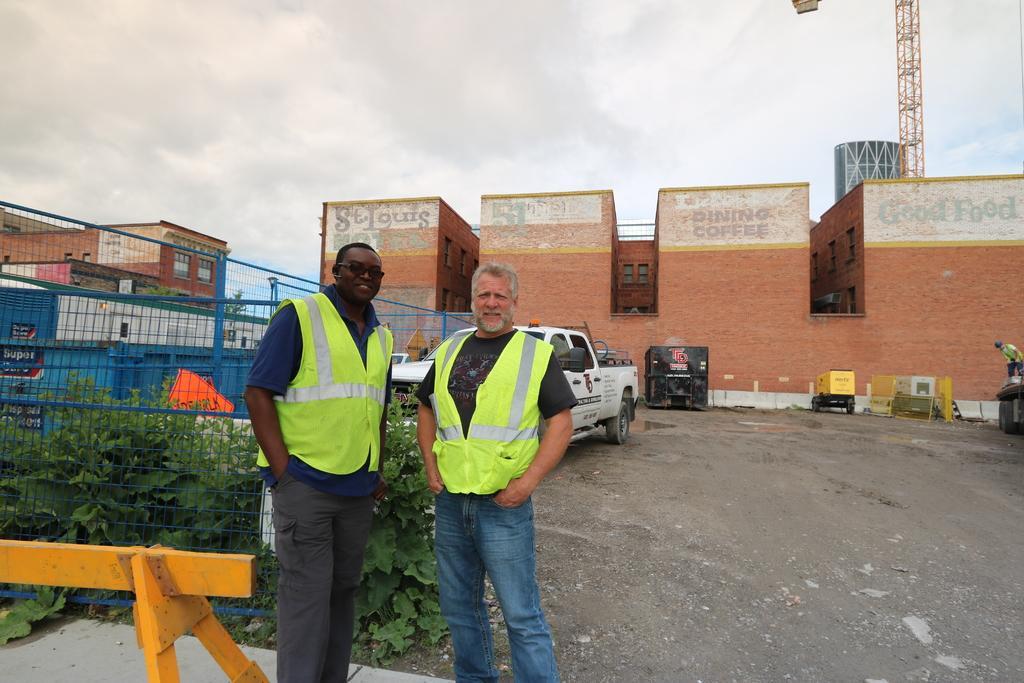In one or two sentences, can you explain what this image depicts? In this picture we can observe two men standing and smiling. Both of them were wearing green color coats. We can observe a blue color fence behind them. There are some plants on the ground. There is a white color vehicle parked on the road. In the background we can observe brown color buildings and a tower on the right side. There is a sky with some clouds. 